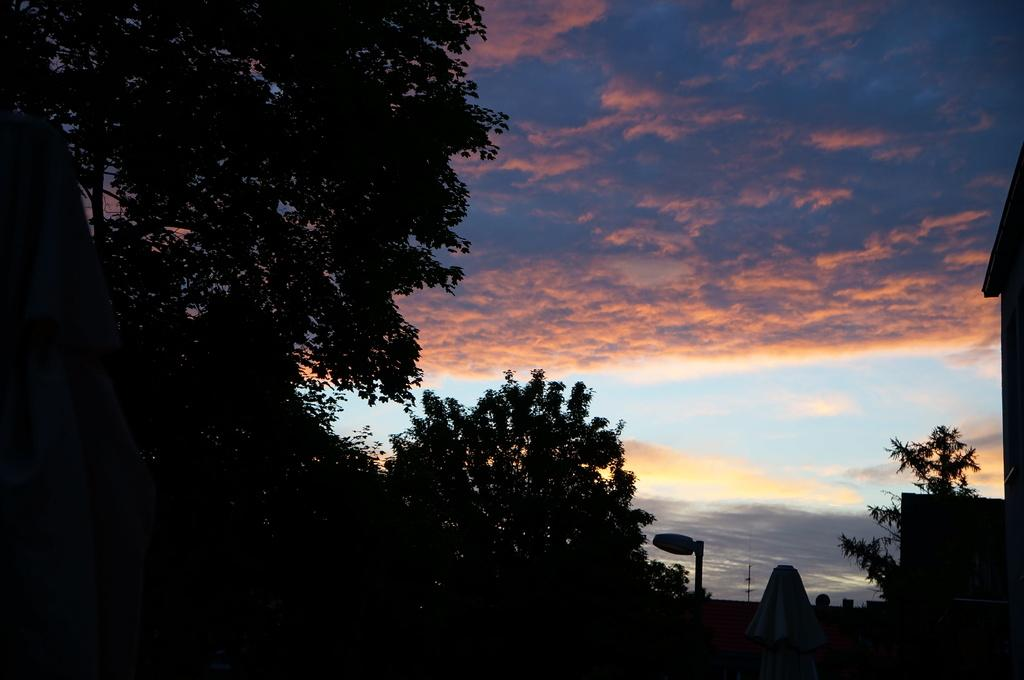What type of natural elements can be seen in the image? There are many trees in the image. What is visible in the background of the image? The sky is visible in the background of the image. How would you describe the appearance of the sky in the image? The sky is colorful in the image. Where is the fireman sitting on a chair in the image? There is no fireman or chair present in the image; it only features trees and a colorful sky. 